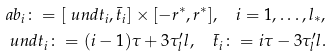<formula> <loc_0><loc_0><loc_500><loc_500>& \sl a b _ { i } \colon = [ \ u n d t _ { i } , \bar { t } _ { i } ] \times [ - r ^ { * } , r ^ { * } ] , \quad i = 1 , \dots , l _ { * } , \\ & \ u n d t _ { i } \colon = ( i - 1 ) \tau + 3 \tau ^ { \prime } _ { l } l , \quad \bar { t } _ { i } \colon = i \tau - 3 \tau ^ { \prime } _ { l } l .</formula> 